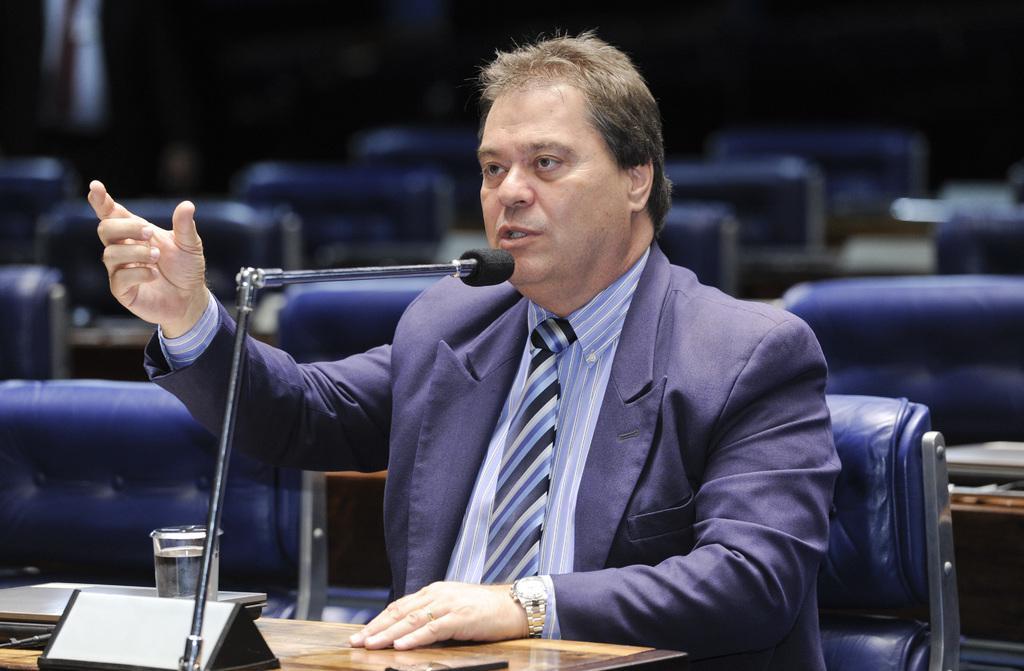Describe this image in one or two sentences. In this picture we can see a man with grey hair who is wearing a blue color jacket and a watch on his left hand and sitting on the chair in front of the desk which has a mike and a glass. 